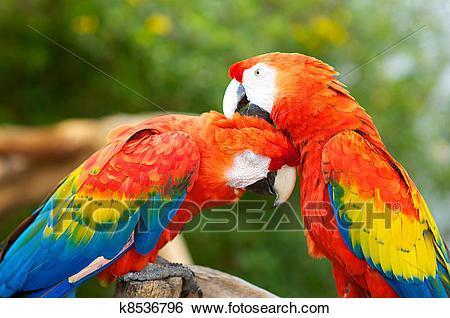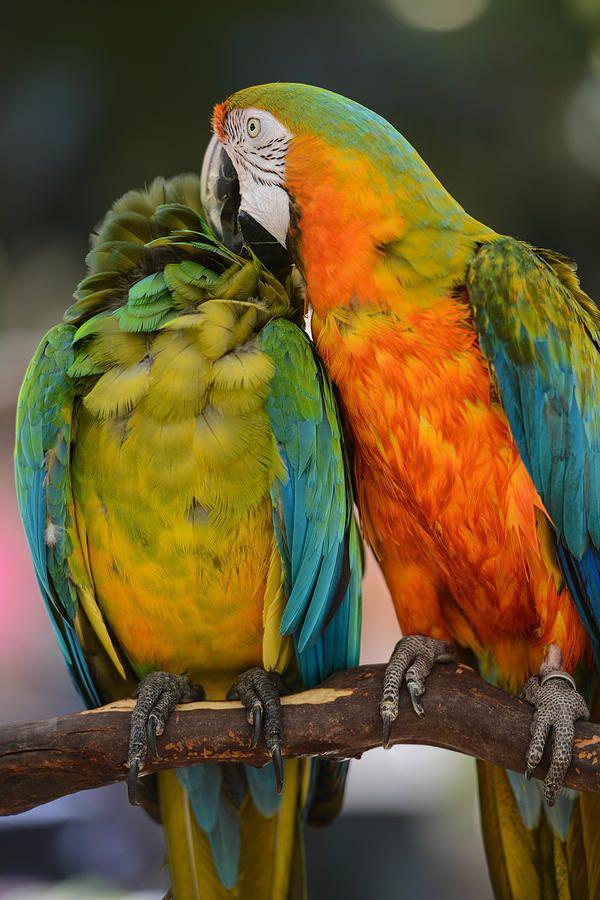The first image is the image on the left, the second image is the image on the right. Given the left and right images, does the statement "Four colorful birds are perched outside." hold true? Answer yes or no. Yes. The first image is the image on the left, the second image is the image on the right. Evaluate the accuracy of this statement regarding the images: "All birds are perched with wings folded, and at least one image shows multiple birds with the same coloring.". Is it true? Answer yes or no. Yes. 